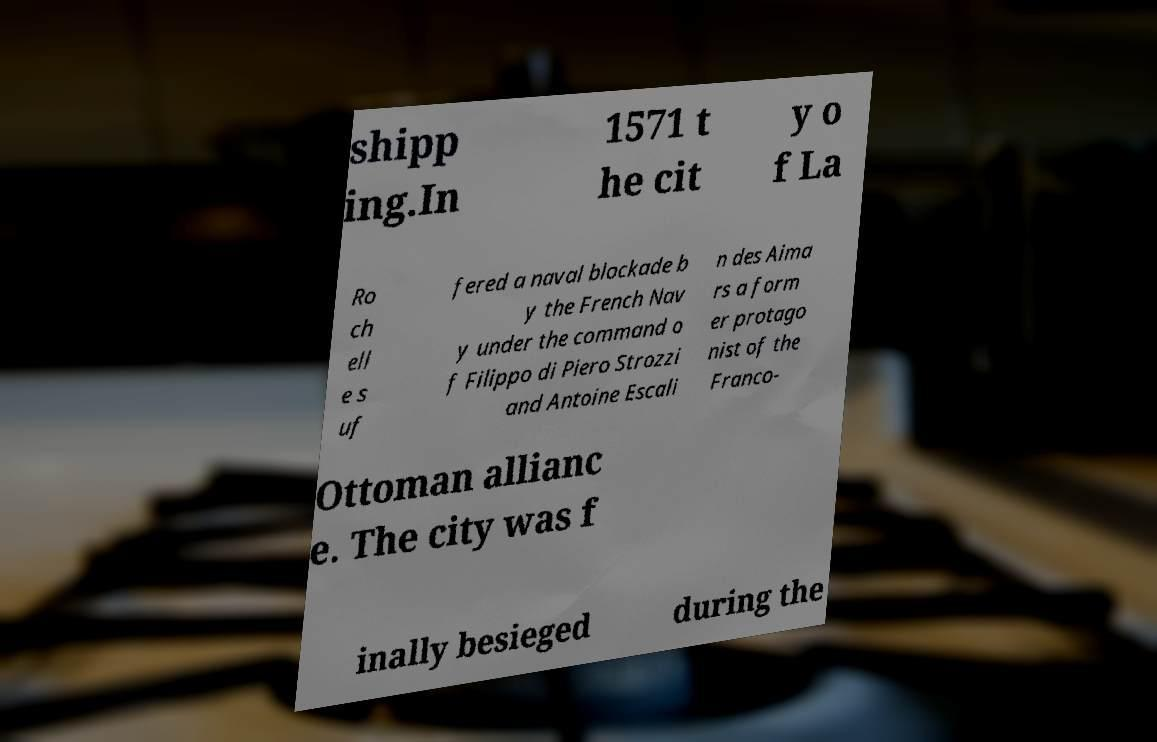I need the written content from this picture converted into text. Can you do that? shipp ing.In 1571 t he cit y o f La Ro ch ell e s uf fered a naval blockade b y the French Nav y under the command o f Filippo di Piero Strozzi and Antoine Escali n des Aima rs a form er protago nist of the Franco- Ottoman allianc e. The city was f inally besieged during the 